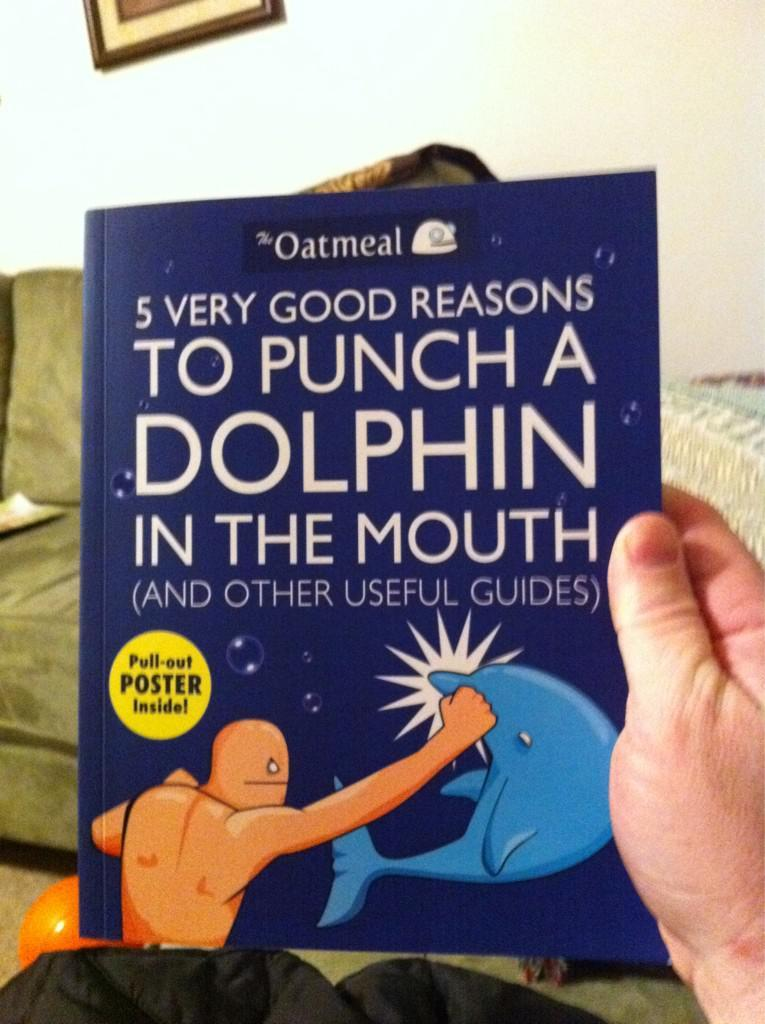<image>
Provide a brief description of the given image. A blue book called 5 very good reasons to punch a dolphin in the mouth 